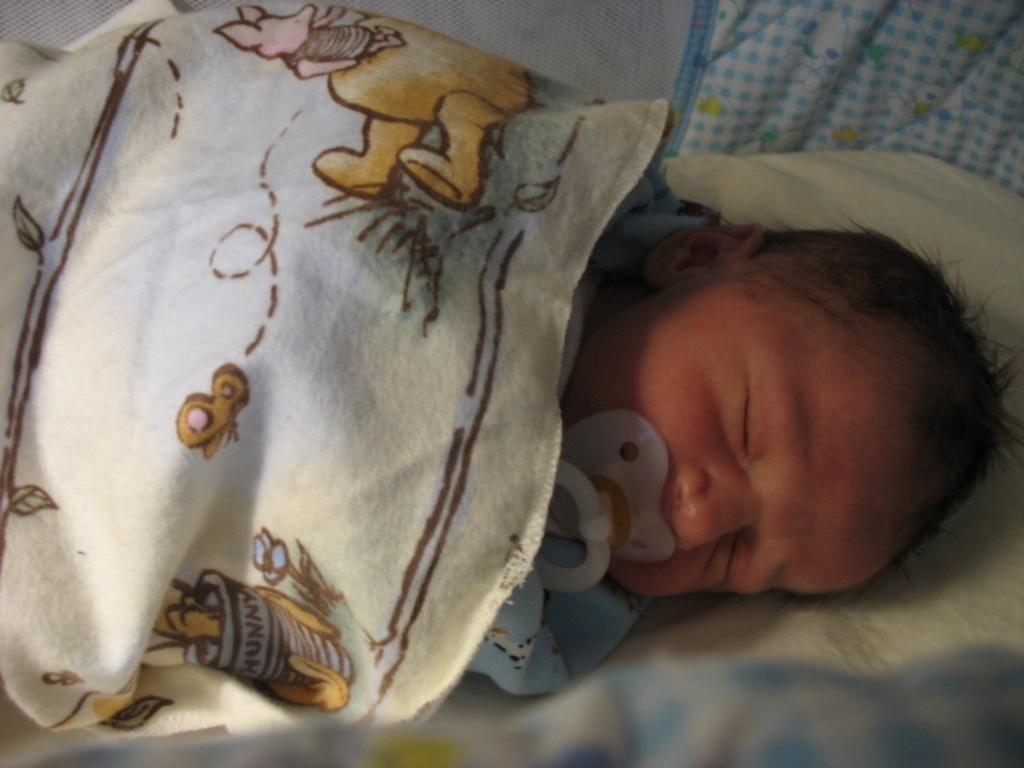What is the main subject of the image? The main subject of the image is a kid. How is the kid positioned in the image? The kid is sleeping on a bed. What is covering the kid in the image? The kid is covered with a blanket. What can be seen on the blanket? There are pictures of toys on the blanket. What type of crow can be seen sitting on the prison bars in the image? There is no crow or prison present in the image; it features a kid sleeping on a bed with a blanket and pictures of toys. 